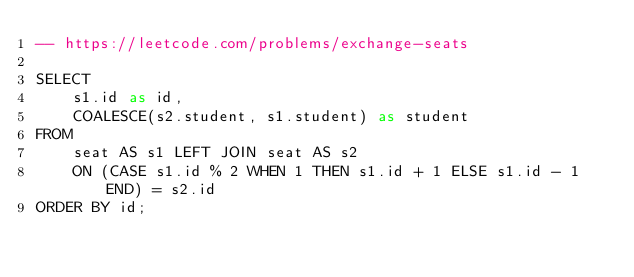<code> <loc_0><loc_0><loc_500><loc_500><_SQL_>-- https://leetcode.com/problems/exchange-seats

SELECT
    s1.id as id,
    COALESCE(s2.student, s1.student) as student
FROM 
    seat AS s1 LEFT JOIN seat AS s2 
    ON (CASE s1.id % 2 WHEN 1 THEN s1.id + 1 ELSE s1.id - 1 END) = s2.id
ORDER BY id;</code> 